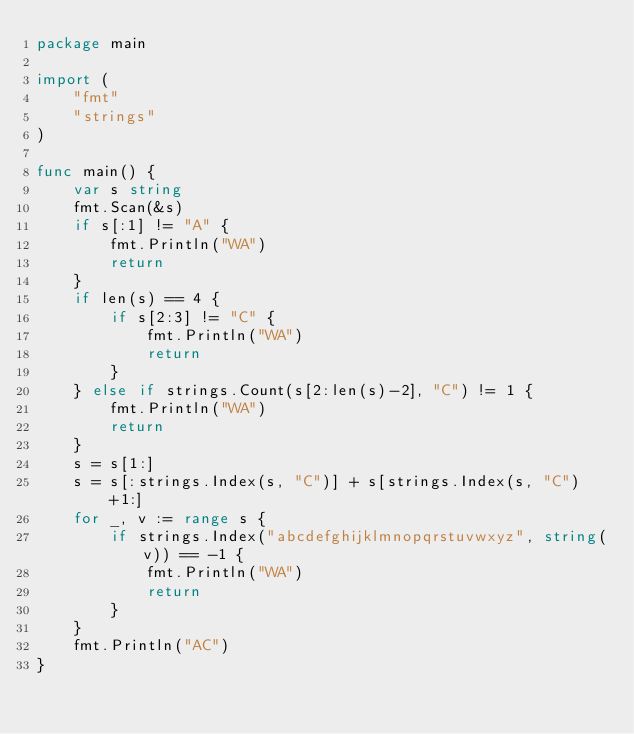Convert code to text. <code><loc_0><loc_0><loc_500><loc_500><_Go_>package main

import (
	"fmt"
	"strings"
)

func main() {
	var s string
	fmt.Scan(&s)
	if s[:1] != "A" {
		fmt.Println("WA")
		return
	}
	if len(s) == 4 {
		if s[2:3] != "C" {
			fmt.Println("WA")
			return
		}
	} else if strings.Count(s[2:len(s)-2], "C") != 1 {
		fmt.Println("WA")
		return
	}
	s = s[1:]
	s = s[:strings.Index(s, "C")] + s[strings.Index(s, "C")+1:]
	for _, v := range s {
		if strings.Index("abcdefghijklmnopqrstuvwxyz", string(v)) == -1 {
			fmt.Println("WA")
			return
		}
	}
	fmt.Println("AC")
}
</code> 